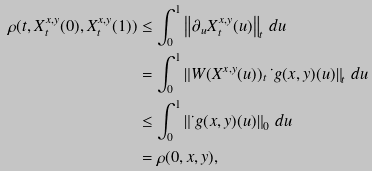<formula> <loc_0><loc_0><loc_500><loc_500>\rho ( t , X _ { t } ^ { x , y } ( 0 ) , X _ { t } ^ { x , y } ( 1 ) ) & \leq \int _ { 0 } ^ { 1 } \left \| \partial _ { u } X _ { t } ^ { x , y } ( u ) \right \| _ { t } \, d u \\ & = \int _ { 0 } ^ { 1 } \left \| W ( X ^ { x , y } ( u ) ) _ { t } \, \dot { \ } g ( x , y ) ( u ) \right \| _ { t } \, d u \\ & \leq \int _ { 0 } ^ { 1 } \left \| \dot { \ } g ( x , y ) ( u ) \right \| _ { 0 } \, d u \\ & = \rho ( 0 , x , y ) ,</formula> 